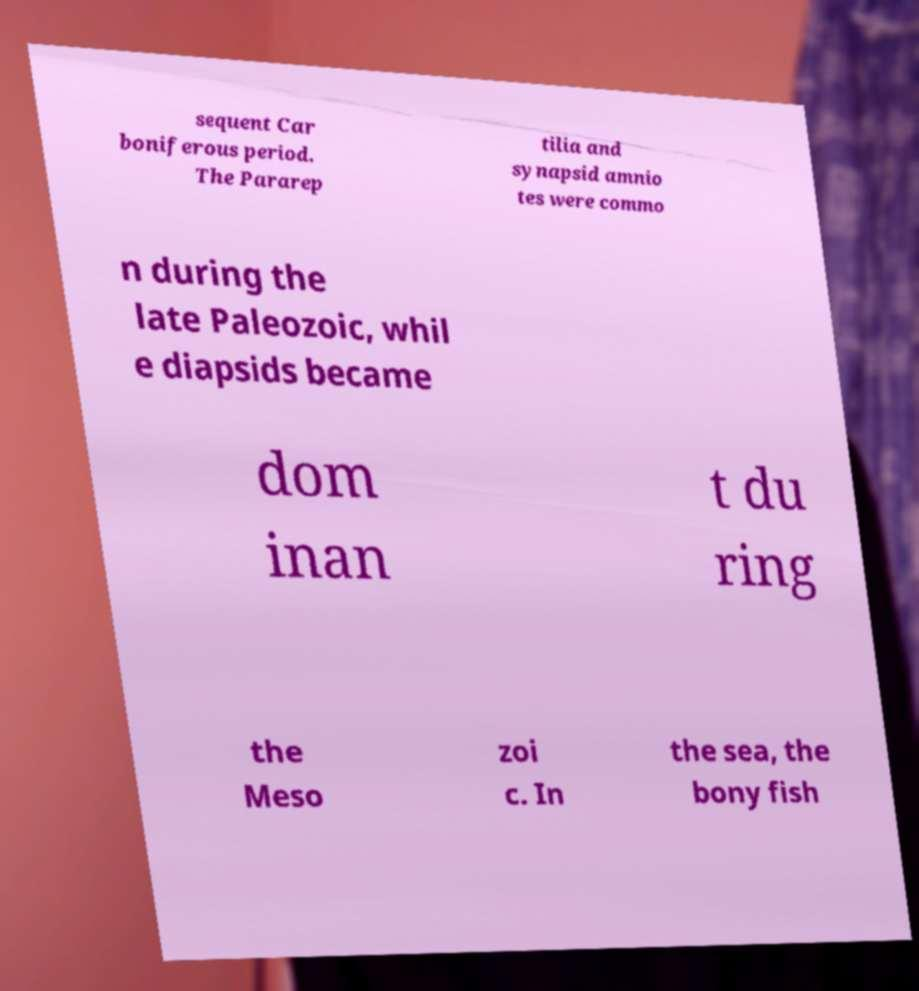Could you extract and type out the text from this image? sequent Car boniferous period. The Pararep tilia and synapsid amnio tes were commo n during the late Paleozoic, whil e diapsids became dom inan t du ring the Meso zoi c. In the sea, the bony fish 